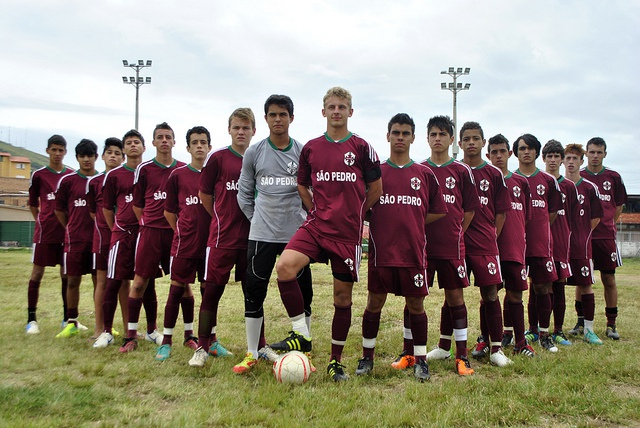Describe the objects in this image and their specific colors. I can see people in white, black, maroon, and olive tones, people in white, maroon, black, and gray tones, people in white, black, darkgray, and gray tones, people in white, black, maroon, and gray tones, and people in white, black, maroon, and gray tones in this image. 